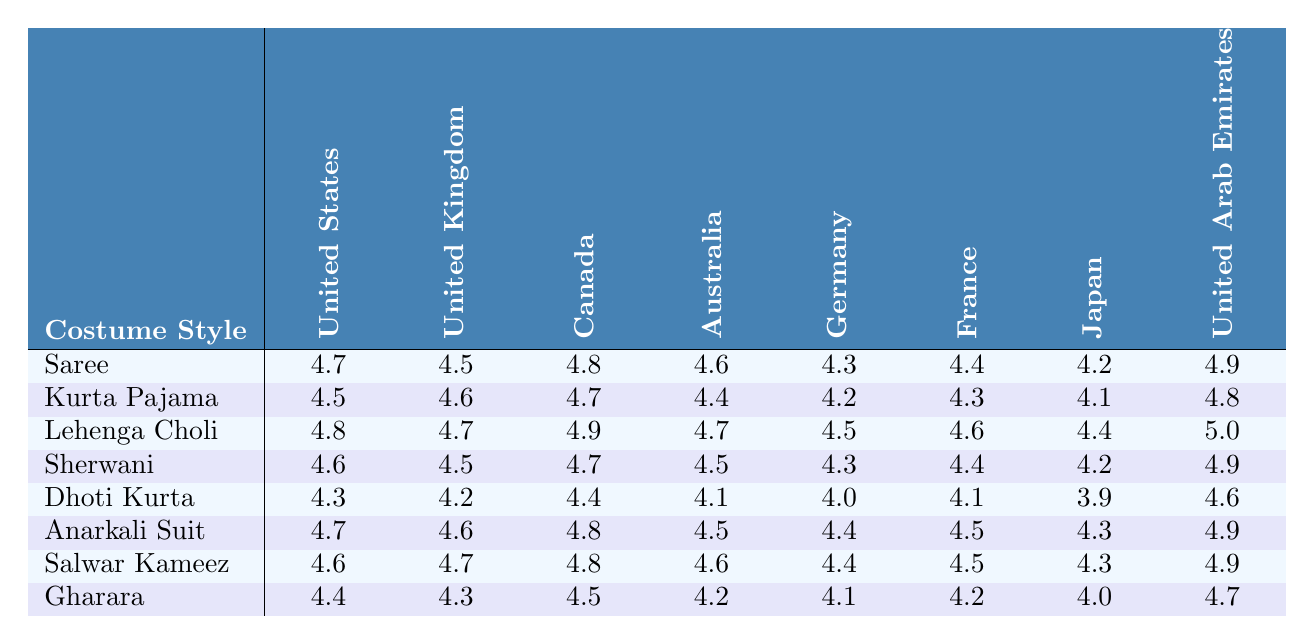What's the satisfaction rating for Sarees in the United States? The table shows the ratings for each costume style in specific countries. For Sarees, the rating in the United States is explicitly listed as 4.7.
Answer: 4.7 Which costume style has the highest satisfaction rating in Canada? By looking at the satisfaction ratings for each style specifically in Canada, Lehenga Choli has the highest rating of 4.9.
Answer: Lehenga Choli Is the satisfaction rating for Dhoti Kurta in Japan greater than 4.0? The rating for Dhoti Kurta in Japan is 3.9, which is less than 4.0. Therefore, the statement is false.
Answer: No What is the average satisfaction rating for Sherwani across all eight markets? To find the average, sum the ratings for Sherwani (4.6 + 4.5 + 4.7 + 4.5 + 4.3 + 4.4 + 4.2 + 4.9) which equals 36.1. Then divide by the number of markets (8): 36.1 / 8 = 4.5125, rounded to 4.51.
Answer: 4.51 Is there a costume style that has a satisfaction rating of 5.0 in any market? By reviewing the table, Lehenga Choli has a satisfaction rating of 5.0 in the United Arab Emirates, confirming there is such a style.
Answer: Yes Which market has the lowest rating for Gharara? The ratings for Gharara show Japan with a rating of 4.0, which is the lowest compared to other markets.
Answer: Japan How does the satisfaction rating for Anarkali Suit in Australia compare to that of Kurta Pajama? The Anarkali Suit has a rating of 4.5 in Australia, while the Kurta Pajama has a rating of 4.4. Therefore, Anarkali Suit has a higher rating.
Answer: Higher What is the difference in satisfaction ratings between the highest and lowest-rated costume styles in the United Kingdom? The highest-rated style in the UK is Salwar Kameez (4.7) and the lowest is Dhoti Kurta (4.2). To find the difference: 4.7 - 4.2 = 0.5.
Answer: 0.5 How many costume styles have a satisfaction rating above 4.5 in the United States? The styles with ratings above 4.5 in the United States are Saree (4.7), Lehenga Choli (4.8), Sherwani (4.6), and Anarkali Suit (4.7). That's four styles in total.
Answer: 4 Which international market has the highest overall satisfaction rating for costumes based on the provided data? The ratings for the United Arab Emirates are consistently high, with Lehenga Choli having the highest rating of 5.0, and it scored above 4.5 for all styles. Therefore, it is the market with the highest overall satisfaction.
Answer: United Arab Emirates 